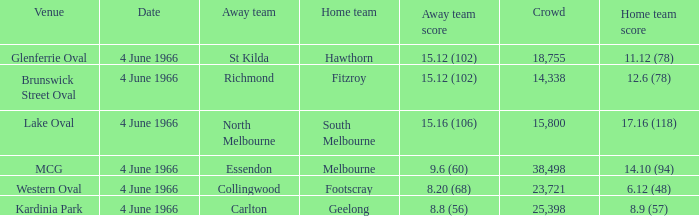What is the largest crowd size that watch a game where the home team scored 12.6 (78)? 14338.0. 